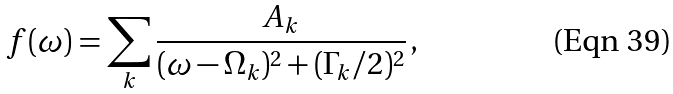<formula> <loc_0><loc_0><loc_500><loc_500>f ( \omega ) = \sum _ { k } \frac { A _ { k } } { ( \omega - \Omega _ { k } ) ^ { 2 } + ( \Gamma _ { k } / 2 ) ^ { 2 } } \, ,</formula> 